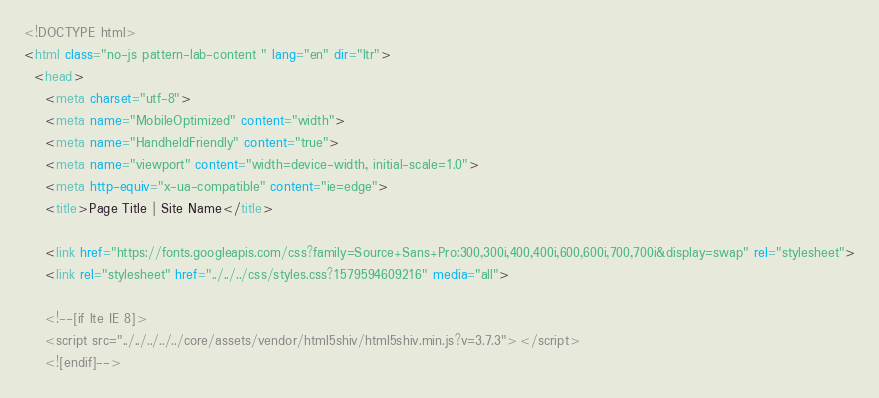Convert code to text. <code><loc_0><loc_0><loc_500><loc_500><_HTML_><!DOCTYPE html>
<html class="no-js pattern-lab-content " lang="en" dir="ltr">
  <head>
    <meta charset="utf-8">
    <meta name="MobileOptimized" content="width">
    <meta name="HandheldFriendly" content="true">
    <meta name="viewport" content="width=device-width, initial-scale=1.0">
    <meta http-equiv="x-ua-compatible" content="ie=edge">
    <title>Page Title | Site Name</title>

    <link href="https://fonts.googleapis.com/css?family=Source+Sans+Pro:300,300i,400,400i,600,600i,700,700i&display=swap" rel="stylesheet">
    <link rel="stylesheet" href="../../../css/styles.css?1579594609216" media="all">

    <!--[if lte IE 8]>
    <script src="../../../../../core/assets/vendor/html5shiv/html5shiv.min.js?v=3.7.3"></script>
    <![endif]-->
</code> 